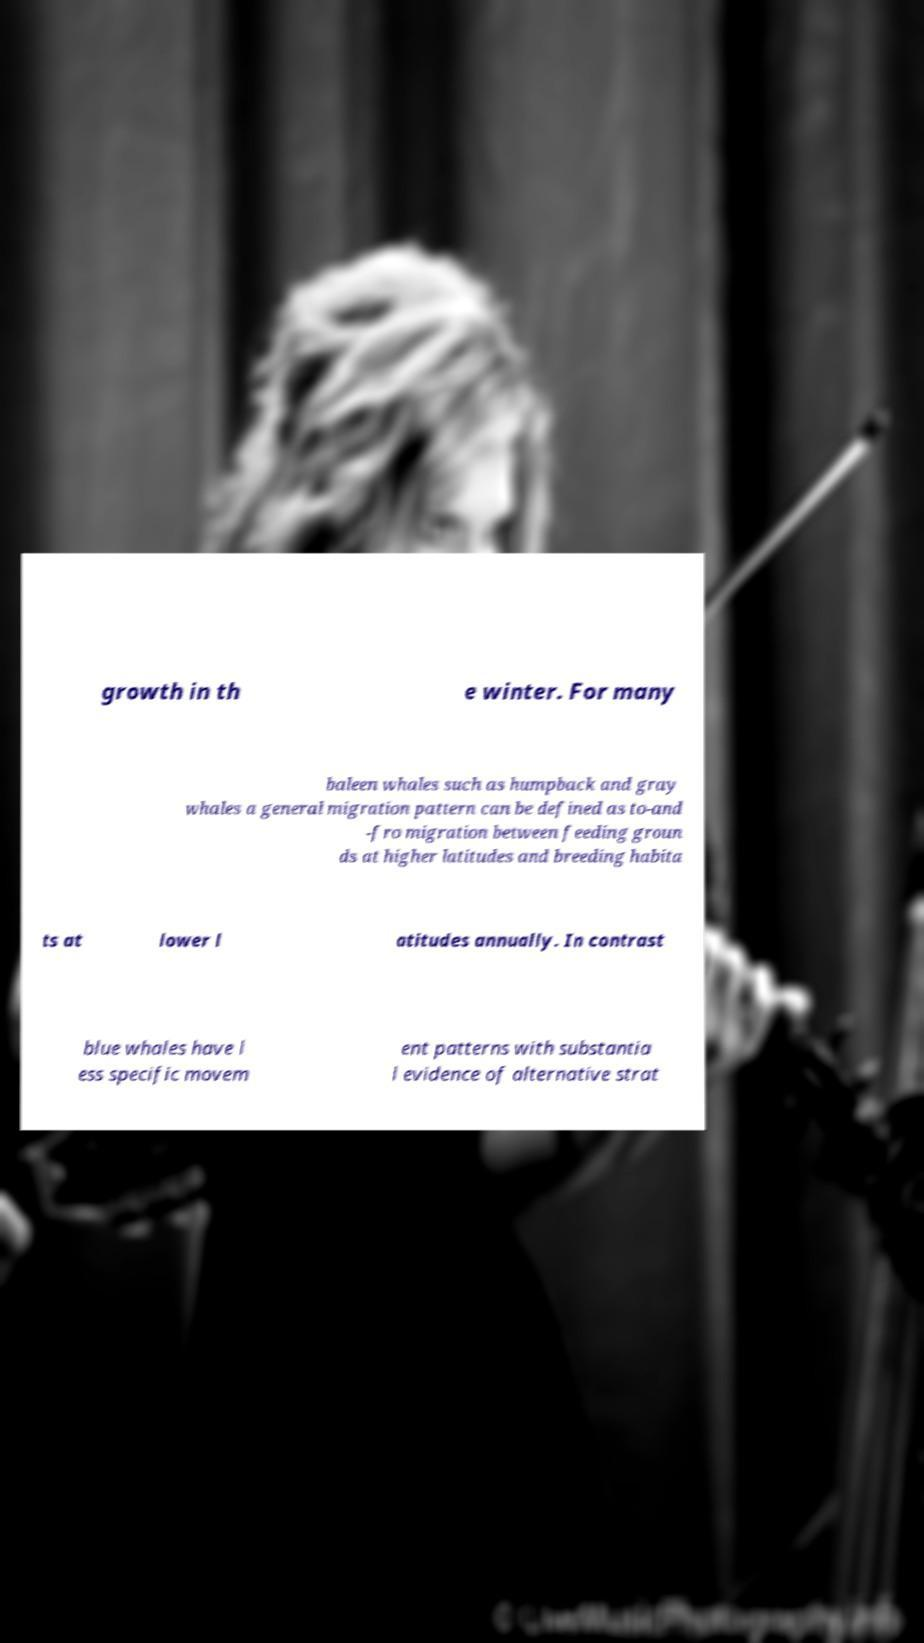What messages or text are displayed in this image? I need them in a readable, typed format. growth in th e winter. For many baleen whales such as humpback and gray whales a general migration pattern can be defined as to-and -fro migration between feeding groun ds at higher latitudes and breeding habita ts at lower l atitudes annually. In contrast blue whales have l ess specific movem ent patterns with substantia l evidence of alternative strat 